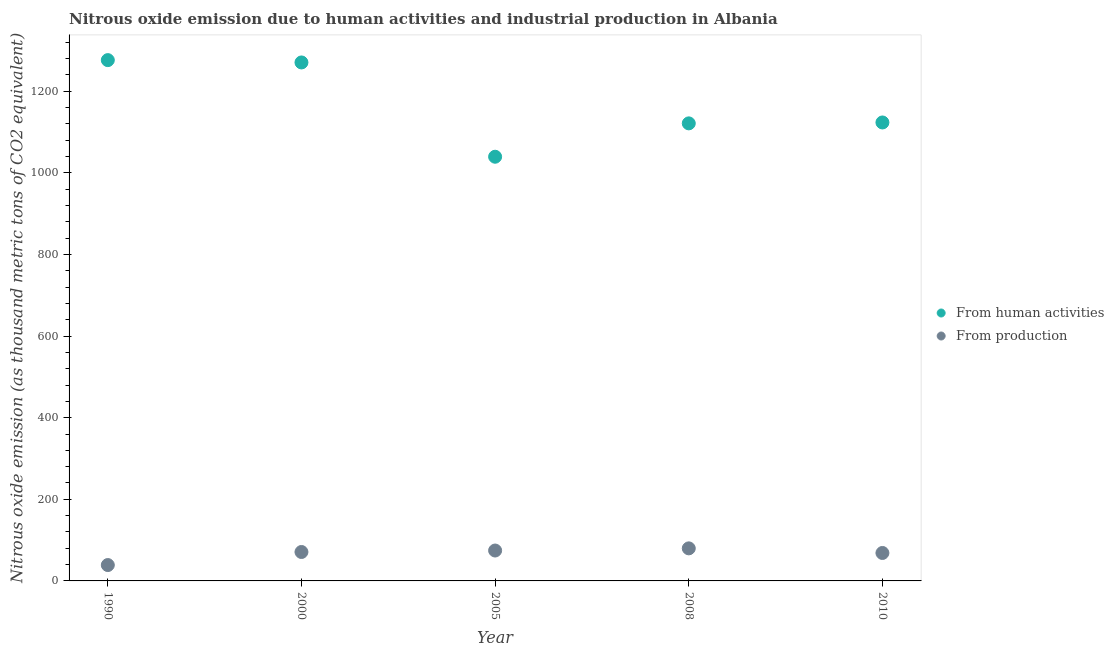What is the amount of emissions generated from industries in 2010?
Provide a succinct answer. 68.5. Across all years, what is the maximum amount of emissions from human activities?
Provide a succinct answer. 1276.4. Across all years, what is the minimum amount of emissions generated from industries?
Your answer should be very brief. 38.9. In which year was the amount of emissions from human activities maximum?
Provide a succinct answer. 1990. What is the total amount of emissions generated from industries in the graph?
Offer a very short reply. 332.6. What is the difference between the amount of emissions from human activities in 2000 and that in 2005?
Your answer should be very brief. 231.1. What is the difference between the amount of emissions generated from industries in 1990 and the amount of emissions from human activities in 2000?
Keep it short and to the point. -1231.8. What is the average amount of emissions generated from industries per year?
Your response must be concise. 66.52. In the year 2010, what is the difference between the amount of emissions generated from industries and amount of emissions from human activities?
Your answer should be compact. -1055.1. What is the ratio of the amount of emissions generated from industries in 2005 to that in 2010?
Offer a very short reply. 1.09. Is the amount of emissions generated from industries in 2000 less than that in 2010?
Ensure brevity in your answer.  No. What is the difference between the highest and the second highest amount of emissions from human activities?
Offer a terse response. 5.7. What is the difference between the highest and the lowest amount of emissions generated from industries?
Give a very brief answer. 40.9. Does the amount of emissions from human activities monotonically increase over the years?
Your response must be concise. No. Is the amount of emissions generated from industries strictly less than the amount of emissions from human activities over the years?
Give a very brief answer. Yes. How many dotlines are there?
Ensure brevity in your answer.  2. How many years are there in the graph?
Offer a terse response. 5. What is the difference between two consecutive major ticks on the Y-axis?
Provide a succinct answer. 200. Are the values on the major ticks of Y-axis written in scientific E-notation?
Offer a very short reply. No. How many legend labels are there?
Your response must be concise. 2. How are the legend labels stacked?
Offer a very short reply. Vertical. What is the title of the graph?
Offer a very short reply. Nitrous oxide emission due to human activities and industrial production in Albania. Does "Domestic Liabilities" appear as one of the legend labels in the graph?
Your answer should be compact. No. What is the label or title of the Y-axis?
Provide a short and direct response. Nitrous oxide emission (as thousand metric tons of CO2 equivalent). What is the Nitrous oxide emission (as thousand metric tons of CO2 equivalent) of From human activities in 1990?
Ensure brevity in your answer.  1276.4. What is the Nitrous oxide emission (as thousand metric tons of CO2 equivalent) of From production in 1990?
Give a very brief answer. 38.9. What is the Nitrous oxide emission (as thousand metric tons of CO2 equivalent) of From human activities in 2000?
Keep it short and to the point. 1270.7. What is the Nitrous oxide emission (as thousand metric tons of CO2 equivalent) of From production in 2000?
Your answer should be very brief. 70.9. What is the Nitrous oxide emission (as thousand metric tons of CO2 equivalent) of From human activities in 2005?
Your answer should be compact. 1039.6. What is the Nitrous oxide emission (as thousand metric tons of CO2 equivalent) in From production in 2005?
Provide a short and direct response. 74.5. What is the Nitrous oxide emission (as thousand metric tons of CO2 equivalent) of From human activities in 2008?
Give a very brief answer. 1121.4. What is the Nitrous oxide emission (as thousand metric tons of CO2 equivalent) of From production in 2008?
Give a very brief answer. 79.8. What is the Nitrous oxide emission (as thousand metric tons of CO2 equivalent) of From human activities in 2010?
Give a very brief answer. 1123.6. What is the Nitrous oxide emission (as thousand metric tons of CO2 equivalent) in From production in 2010?
Your answer should be very brief. 68.5. Across all years, what is the maximum Nitrous oxide emission (as thousand metric tons of CO2 equivalent) of From human activities?
Your answer should be very brief. 1276.4. Across all years, what is the maximum Nitrous oxide emission (as thousand metric tons of CO2 equivalent) of From production?
Give a very brief answer. 79.8. Across all years, what is the minimum Nitrous oxide emission (as thousand metric tons of CO2 equivalent) of From human activities?
Offer a terse response. 1039.6. Across all years, what is the minimum Nitrous oxide emission (as thousand metric tons of CO2 equivalent) in From production?
Make the answer very short. 38.9. What is the total Nitrous oxide emission (as thousand metric tons of CO2 equivalent) of From human activities in the graph?
Provide a short and direct response. 5831.7. What is the total Nitrous oxide emission (as thousand metric tons of CO2 equivalent) of From production in the graph?
Provide a short and direct response. 332.6. What is the difference between the Nitrous oxide emission (as thousand metric tons of CO2 equivalent) of From human activities in 1990 and that in 2000?
Provide a short and direct response. 5.7. What is the difference between the Nitrous oxide emission (as thousand metric tons of CO2 equivalent) of From production in 1990 and that in 2000?
Offer a very short reply. -32. What is the difference between the Nitrous oxide emission (as thousand metric tons of CO2 equivalent) in From human activities in 1990 and that in 2005?
Keep it short and to the point. 236.8. What is the difference between the Nitrous oxide emission (as thousand metric tons of CO2 equivalent) of From production in 1990 and that in 2005?
Provide a short and direct response. -35.6. What is the difference between the Nitrous oxide emission (as thousand metric tons of CO2 equivalent) in From human activities in 1990 and that in 2008?
Your answer should be very brief. 155. What is the difference between the Nitrous oxide emission (as thousand metric tons of CO2 equivalent) in From production in 1990 and that in 2008?
Offer a very short reply. -40.9. What is the difference between the Nitrous oxide emission (as thousand metric tons of CO2 equivalent) of From human activities in 1990 and that in 2010?
Your answer should be compact. 152.8. What is the difference between the Nitrous oxide emission (as thousand metric tons of CO2 equivalent) of From production in 1990 and that in 2010?
Your answer should be very brief. -29.6. What is the difference between the Nitrous oxide emission (as thousand metric tons of CO2 equivalent) of From human activities in 2000 and that in 2005?
Provide a succinct answer. 231.1. What is the difference between the Nitrous oxide emission (as thousand metric tons of CO2 equivalent) of From production in 2000 and that in 2005?
Provide a succinct answer. -3.6. What is the difference between the Nitrous oxide emission (as thousand metric tons of CO2 equivalent) of From human activities in 2000 and that in 2008?
Your response must be concise. 149.3. What is the difference between the Nitrous oxide emission (as thousand metric tons of CO2 equivalent) of From production in 2000 and that in 2008?
Your response must be concise. -8.9. What is the difference between the Nitrous oxide emission (as thousand metric tons of CO2 equivalent) in From human activities in 2000 and that in 2010?
Give a very brief answer. 147.1. What is the difference between the Nitrous oxide emission (as thousand metric tons of CO2 equivalent) of From human activities in 2005 and that in 2008?
Give a very brief answer. -81.8. What is the difference between the Nitrous oxide emission (as thousand metric tons of CO2 equivalent) in From human activities in 2005 and that in 2010?
Give a very brief answer. -84. What is the difference between the Nitrous oxide emission (as thousand metric tons of CO2 equivalent) of From production in 2005 and that in 2010?
Your answer should be very brief. 6. What is the difference between the Nitrous oxide emission (as thousand metric tons of CO2 equivalent) in From production in 2008 and that in 2010?
Offer a terse response. 11.3. What is the difference between the Nitrous oxide emission (as thousand metric tons of CO2 equivalent) of From human activities in 1990 and the Nitrous oxide emission (as thousand metric tons of CO2 equivalent) of From production in 2000?
Make the answer very short. 1205.5. What is the difference between the Nitrous oxide emission (as thousand metric tons of CO2 equivalent) of From human activities in 1990 and the Nitrous oxide emission (as thousand metric tons of CO2 equivalent) of From production in 2005?
Give a very brief answer. 1201.9. What is the difference between the Nitrous oxide emission (as thousand metric tons of CO2 equivalent) in From human activities in 1990 and the Nitrous oxide emission (as thousand metric tons of CO2 equivalent) in From production in 2008?
Your response must be concise. 1196.6. What is the difference between the Nitrous oxide emission (as thousand metric tons of CO2 equivalent) in From human activities in 1990 and the Nitrous oxide emission (as thousand metric tons of CO2 equivalent) in From production in 2010?
Provide a succinct answer. 1207.9. What is the difference between the Nitrous oxide emission (as thousand metric tons of CO2 equivalent) of From human activities in 2000 and the Nitrous oxide emission (as thousand metric tons of CO2 equivalent) of From production in 2005?
Give a very brief answer. 1196.2. What is the difference between the Nitrous oxide emission (as thousand metric tons of CO2 equivalent) in From human activities in 2000 and the Nitrous oxide emission (as thousand metric tons of CO2 equivalent) in From production in 2008?
Give a very brief answer. 1190.9. What is the difference between the Nitrous oxide emission (as thousand metric tons of CO2 equivalent) in From human activities in 2000 and the Nitrous oxide emission (as thousand metric tons of CO2 equivalent) in From production in 2010?
Ensure brevity in your answer.  1202.2. What is the difference between the Nitrous oxide emission (as thousand metric tons of CO2 equivalent) of From human activities in 2005 and the Nitrous oxide emission (as thousand metric tons of CO2 equivalent) of From production in 2008?
Your answer should be compact. 959.8. What is the difference between the Nitrous oxide emission (as thousand metric tons of CO2 equivalent) of From human activities in 2005 and the Nitrous oxide emission (as thousand metric tons of CO2 equivalent) of From production in 2010?
Your answer should be compact. 971.1. What is the difference between the Nitrous oxide emission (as thousand metric tons of CO2 equivalent) in From human activities in 2008 and the Nitrous oxide emission (as thousand metric tons of CO2 equivalent) in From production in 2010?
Provide a short and direct response. 1052.9. What is the average Nitrous oxide emission (as thousand metric tons of CO2 equivalent) in From human activities per year?
Offer a terse response. 1166.34. What is the average Nitrous oxide emission (as thousand metric tons of CO2 equivalent) in From production per year?
Ensure brevity in your answer.  66.52. In the year 1990, what is the difference between the Nitrous oxide emission (as thousand metric tons of CO2 equivalent) of From human activities and Nitrous oxide emission (as thousand metric tons of CO2 equivalent) of From production?
Your answer should be very brief. 1237.5. In the year 2000, what is the difference between the Nitrous oxide emission (as thousand metric tons of CO2 equivalent) of From human activities and Nitrous oxide emission (as thousand metric tons of CO2 equivalent) of From production?
Provide a short and direct response. 1199.8. In the year 2005, what is the difference between the Nitrous oxide emission (as thousand metric tons of CO2 equivalent) in From human activities and Nitrous oxide emission (as thousand metric tons of CO2 equivalent) in From production?
Keep it short and to the point. 965.1. In the year 2008, what is the difference between the Nitrous oxide emission (as thousand metric tons of CO2 equivalent) in From human activities and Nitrous oxide emission (as thousand metric tons of CO2 equivalent) in From production?
Provide a succinct answer. 1041.6. In the year 2010, what is the difference between the Nitrous oxide emission (as thousand metric tons of CO2 equivalent) in From human activities and Nitrous oxide emission (as thousand metric tons of CO2 equivalent) in From production?
Provide a short and direct response. 1055.1. What is the ratio of the Nitrous oxide emission (as thousand metric tons of CO2 equivalent) in From production in 1990 to that in 2000?
Your answer should be compact. 0.55. What is the ratio of the Nitrous oxide emission (as thousand metric tons of CO2 equivalent) of From human activities in 1990 to that in 2005?
Make the answer very short. 1.23. What is the ratio of the Nitrous oxide emission (as thousand metric tons of CO2 equivalent) in From production in 1990 to that in 2005?
Give a very brief answer. 0.52. What is the ratio of the Nitrous oxide emission (as thousand metric tons of CO2 equivalent) in From human activities in 1990 to that in 2008?
Your response must be concise. 1.14. What is the ratio of the Nitrous oxide emission (as thousand metric tons of CO2 equivalent) in From production in 1990 to that in 2008?
Your answer should be compact. 0.49. What is the ratio of the Nitrous oxide emission (as thousand metric tons of CO2 equivalent) of From human activities in 1990 to that in 2010?
Make the answer very short. 1.14. What is the ratio of the Nitrous oxide emission (as thousand metric tons of CO2 equivalent) in From production in 1990 to that in 2010?
Provide a short and direct response. 0.57. What is the ratio of the Nitrous oxide emission (as thousand metric tons of CO2 equivalent) of From human activities in 2000 to that in 2005?
Give a very brief answer. 1.22. What is the ratio of the Nitrous oxide emission (as thousand metric tons of CO2 equivalent) in From production in 2000 to that in 2005?
Make the answer very short. 0.95. What is the ratio of the Nitrous oxide emission (as thousand metric tons of CO2 equivalent) of From human activities in 2000 to that in 2008?
Offer a very short reply. 1.13. What is the ratio of the Nitrous oxide emission (as thousand metric tons of CO2 equivalent) in From production in 2000 to that in 2008?
Offer a terse response. 0.89. What is the ratio of the Nitrous oxide emission (as thousand metric tons of CO2 equivalent) of From human activities in 2000 to that in 2010?
Ensure brevity in your answer.  1.13. What is the ratio of the Nitrous oxide emission (as thousand metric tons of CO2 equivalent) of From production in 2000 to that in 2010?
Make the answer very short. 1.03. What is the ratio of the Nitrous oxide emission (as thousand metric tons of CO2 equivalent) in From human activities in 2005 to that in 2008?
Your answer should be compact. 0.93. What is the ratio of the Nitrous oxide emission (as thousand metric tons of CO2 equivalent) of From production in 2005 to that in 2008?
Provide a succinct answer. 0.93. What is the ratio of the Nitrous oxide emission (as thousand metric tons of CO2 equivalent) of From human activities in 2005 to that in 2010?
Keep it short and to the point. 0.93. What is the ratio of the Nitrous oxide emission (as thousand metric tons of CO2 equivalent) in From production in 2005 to that in 2010?
Your answer should be compact. 1.09. What is the ratio of the Nitrous oxide emission (as thousand metric tons of CO2 equivalent) of From human activities in 2008 to that in 2010?
Your answer should be compact. 1. What is the ratio of the Nitrous oxide emission (as thousand metric tons of CO2 equivalent) in From production in 2008 to that in 2010?
Provide a succinct answer. 1.17. What is the difference between the highest and the second highest Nitrous oxide emission (as thousand metric tons of CO2 equivalent) of From production?
Ensure brevity in your answer.  5.3. What is the difference between the highest and the lowest Nitrous oxide emission (as thousand metric tons of CO2 equivalent) in From human activities?
Give a very brief answer. 236.8. What is the difference between the highest and the lowest Nitrous oxide emission (as thousand metric tons of CO2 equivalent) of From production?
Provide a short and direct response. 40.9. 